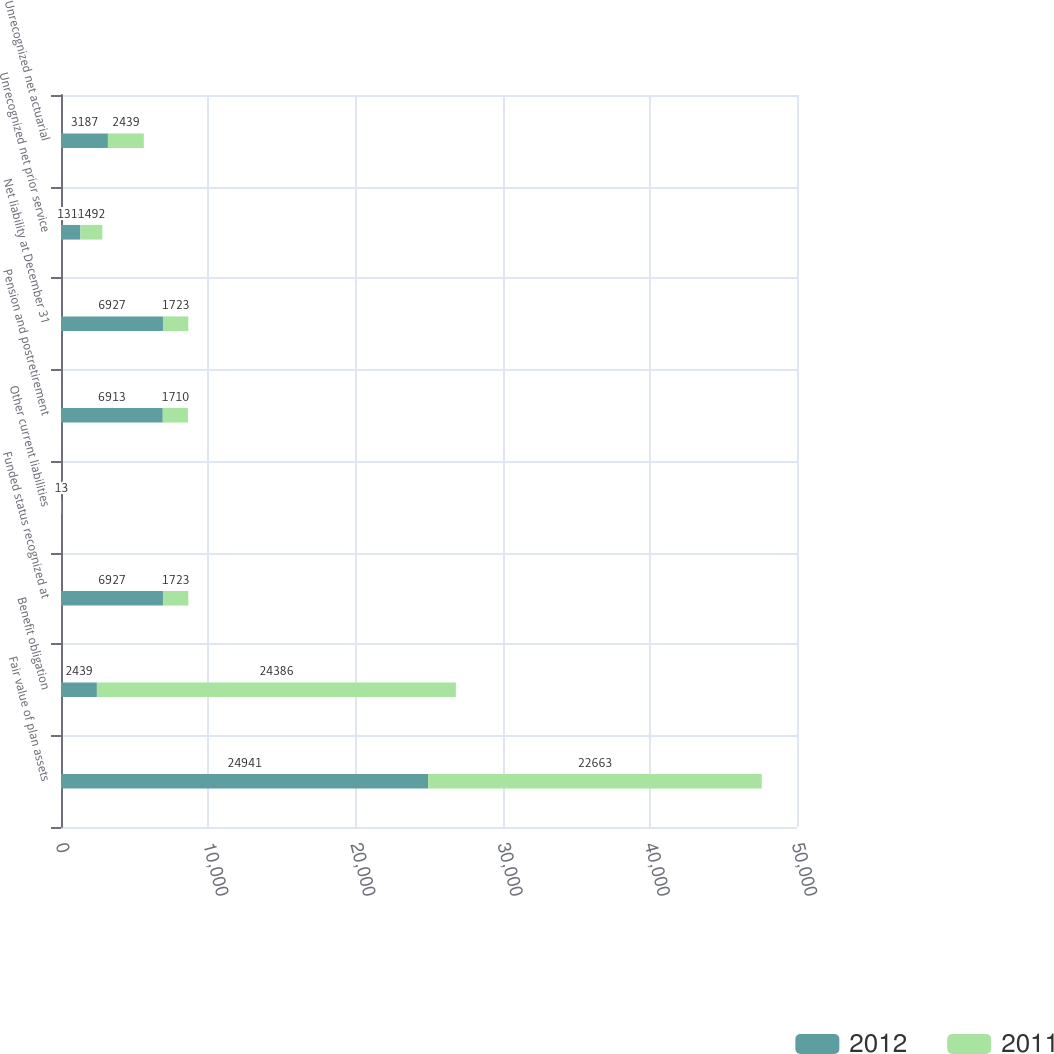<chart> <loc_0><loc_0><loc_500><loc_500><stacked_bar_chart><ecel><fcel>Fair value of plan assets<fcel>Benefit obligation<fcel>Funded status recognized at<fcel>Other current liabilities<fcel>Pension and postretirement<fcel>Net liability at December 31<fcel>Unrecognized net prior service<fcel>Unrecognized net actuarial<nl><fcel>2012<fcel>24941<fcel>2439<fcel>6927<fcel>14<fcel>6913<fcel>6927<fcel>1318<fcel>3187<nl><fcel>2011<fcel>22663<fcel>24386<fcel>1723<fcel>13<fcel>1710<fcel>1723<fcel>1492<fcel>2439<nl></chart> 